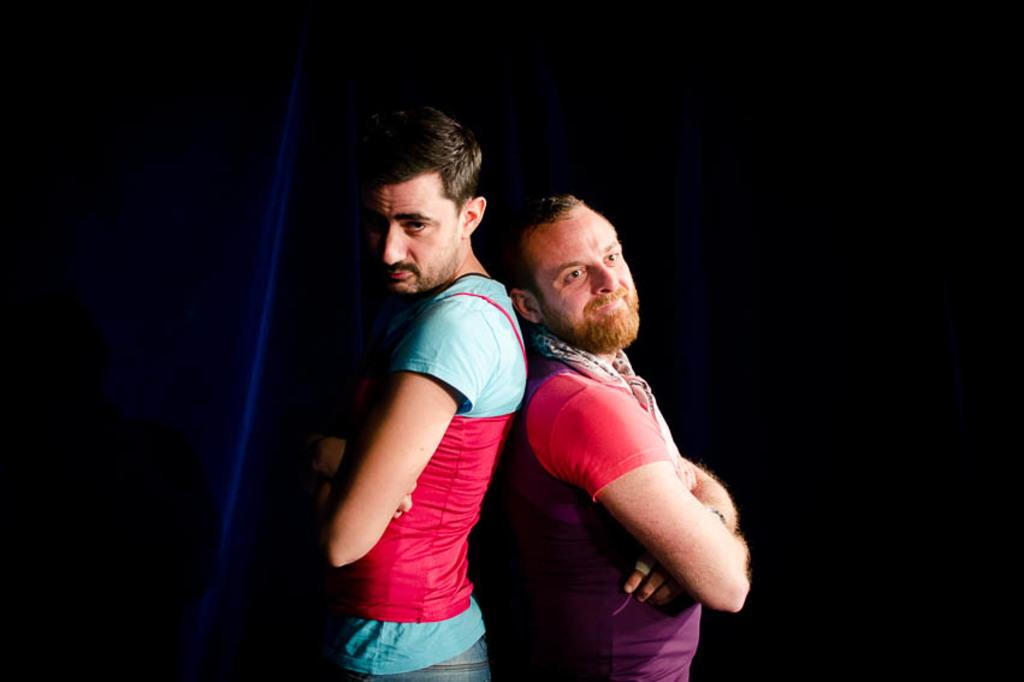How many people are in the image? There are two men in the image. What colors are the shirts worn by the men? One man is wearing a blue shirt, and the other man is wearing a purple shirt. What can be observed about the background of the image? The background of the image is dark. What type of lipstick is the monkey wearing in the image? There is no monkey present in the image, and therefore no lipstick or any other accessories can be observed. 